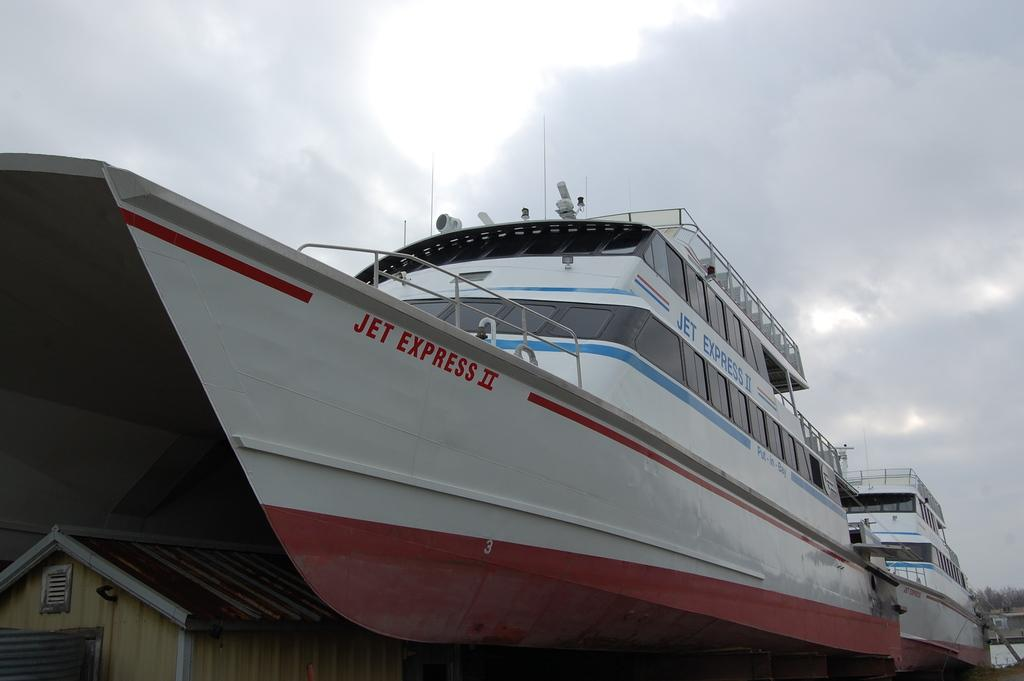What is the main subject of the picture? The main subject of the picture is a ship. What can be seen in the background of the picture? There are trees and the sky visible in the background of the picture. What is the condition of the sky in the picture? Clouds are present in the sky. How does the ship compare to a wooden key in the image? There is no wooden key present in the image, so it cannot be compared to the ship. 